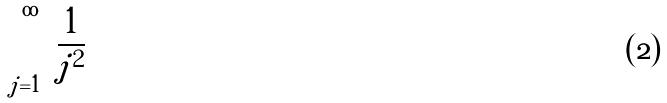Convert formula to latex. <formula><loc_0><loc_0><loc_500><loc_500>\sum _ { j = 1 } ^ { \infty } \frac { 1 } { j ^ { 2 } }</formula> 